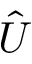Convert formula to latex. <formula><loc_0><loc_0><loc_500><loc_500>\hat { U }</formula> 